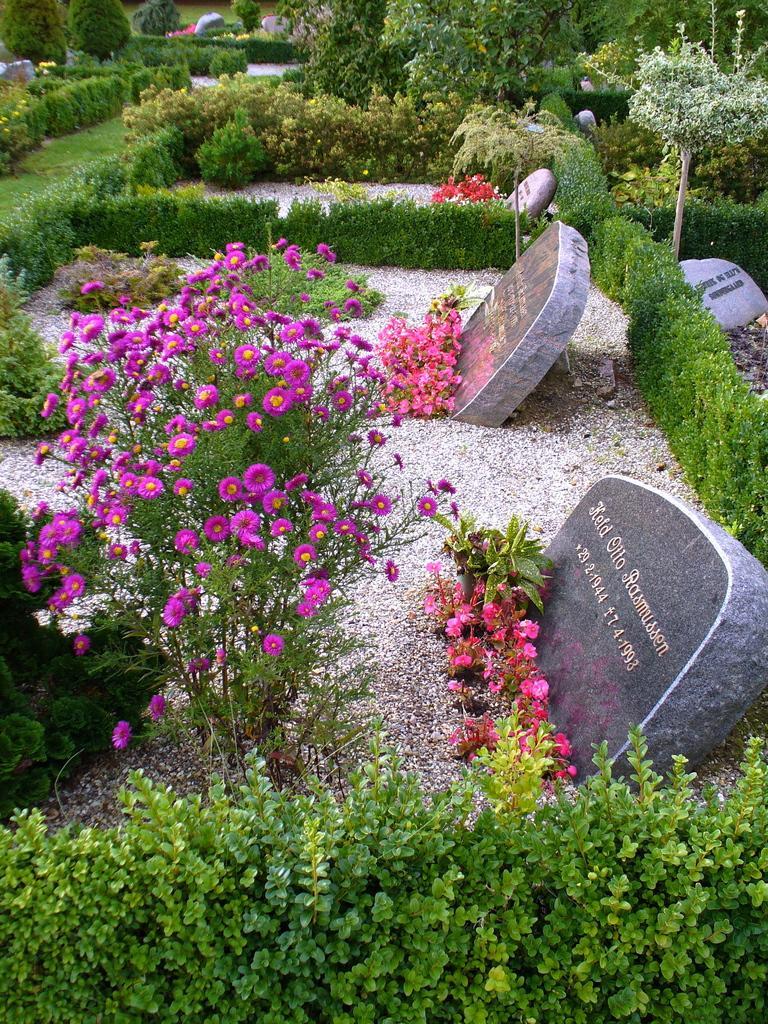Describe this image in one or two sentences. In this image we can see plants with flowers at the stone plates and there are texts written on the stone plates. At the bottom we can see plants. In the background also we can see plants. 